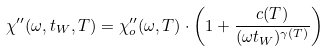<formula> <loc_0><loc_0><loc_500><loc_500>\chi ^ { \prime \prime } ( \omega , t _ { W } , T ) = \chi ^ { \prime \prime } _ { o } ( \omega , T ) \cdot \left ( 1 + \frac { c ( T ) } { ( \omega t _ { W } ) ^ { \gamma ( T ) } } \right )</formula> 